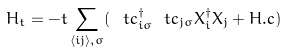Convert formula to latex. <formula><loc_0><loc_0><loc_500><loc_500>H _ { t } = - t \sum _ { \langle i j \rangle , \sigma } ( \ t { c } ^ { \dag } _ { i \sigma } \ t { c } _ { j \sigma } X ^ { \dag } _ { i } X _ { j } + H . c )</formula> 